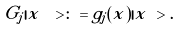<formula> <loc_0><loc_0><loc_500><loc_500>G _ { j } | x \ > & \colon = g _ { j } ( x ) | x \ > .</formula> 